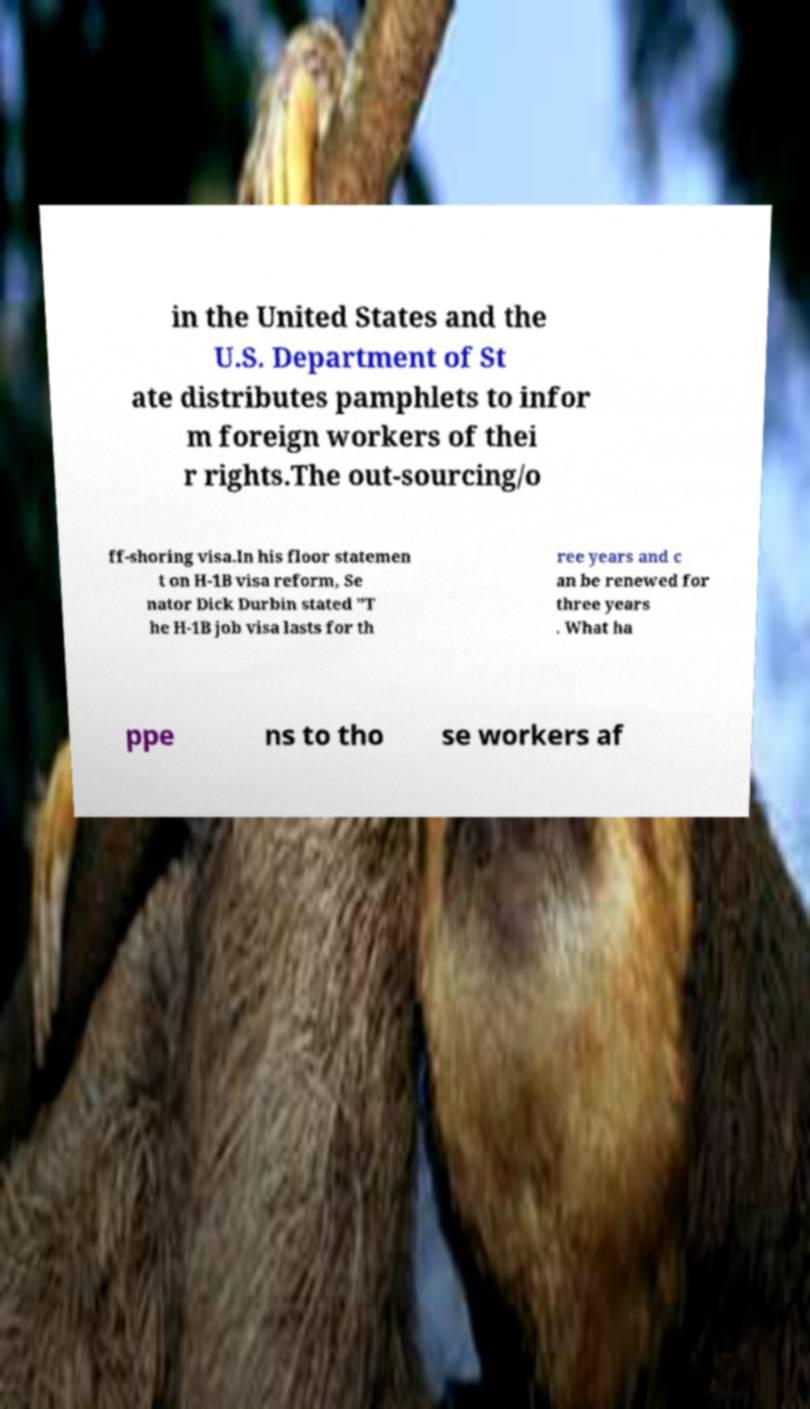Can you read and provide the text displayed in the image?This photo seems to have some interesting text. Can you extract and type it out for me? in the United States and the U.S. Department of St ate distributes pamphlets to infor m foreign workers of thei r rights.The out-sourcing/o ff-shoring visa.In his floor statemen t on H-1B visa reform, Se nator Dick Durbin stated "T he H-1B job visa lasts for th ree years and c an be renewed for three years . What ha ppe ns to tho se workers af 